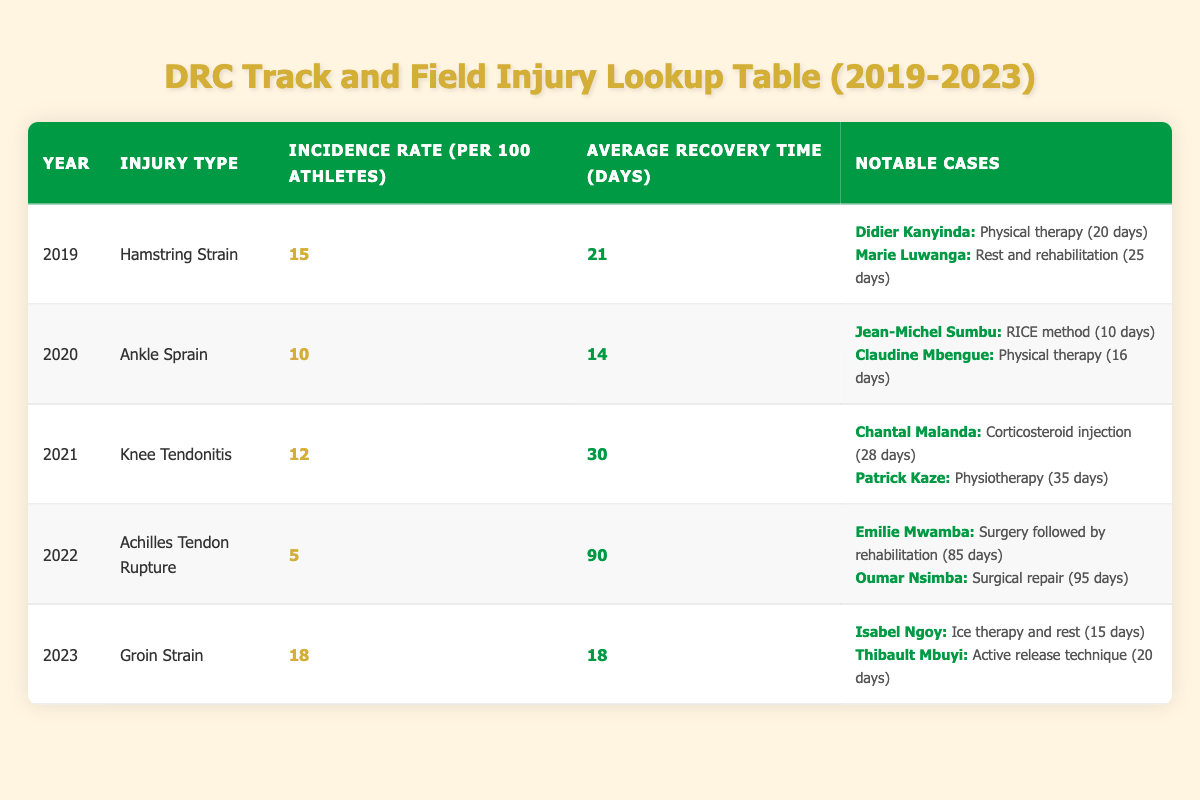What was the incidence rate of Hamstring Strain in 2019? The table shows the incidence rate for Hamstring Strain in 2019 listed as 15 per 100 athletes.
Answer: 15 What is the average recovery time for an Achilles Tendon Rupture? According to the table, the average recovery time for an Achilles Tendon Rupture is listed as 90 days.
Answer: 90 days Which athlete returned to play the fastest after an Ankle Sprain, and how many days did it take? Looking at the notable cases for Ankle Sprain in 2020, Jean-Michel Sumbu returned to play in 10 days, which is faster than Claudine Mbengue's 16 days.
Answer: Jean-Michel Sumbu, 10 days What is the total incidence rate for injuries recorded in 2023? The table lists the incidence rate for Groin Strain in 2023 as 18 per 100 athletes. As this is the only injury listed for 2023, the total incidence rate is also 18.
Answer: 18 Did any athletes suffer from an Achilles Tendon Rupture in 2023? The table does not list any injuries for 2023 other than Groin Strain, indicating no cases of Achilles Tendon Rupture that year.
Answer: No What was the average recovery time across all the injuries in 2021? The average recovery time for Knee Tendonitis in 2021 is 30 days; there was only one injury type reported that year. Thus, the average recovery time is simply 30 days.
Answer: 30 days How many more days did Emilie Mwamba take to return to play compared to Isabel Ngoy in 2022 and 2023 respectively? Emilie Mwamba took 85 days to return to play after an Achilles Tendon Rupture, and Isabel Ngoy took 15 days for a Groin Strain. The difference is 85 - 15 = 70 days.
Answer: 70 days In which year did Knee Tendonitis have a higher incidence rate compared to Ankle Sprain? The incidence rate for Knee Tendonitis in 2021 is 12 per 100 athletes, while Ankle Sprain in 2020 has an incidence rate of 10 per 100 athletes. Therefore, Knee Tendonitis had a higher incidence rate than Ankle Sprain.
Answer: 2021 What were the notable cases of recovery times following a Groin Strain in 2023? The notable cases for Groin Strain in 2023 include Isabel Ngoy, who returned in 15 days, and Thibault Mbuyi, who returned in 20 days.
Answer: Isabel Ngoy 15 days, Thibault Mbuyi 20 days 